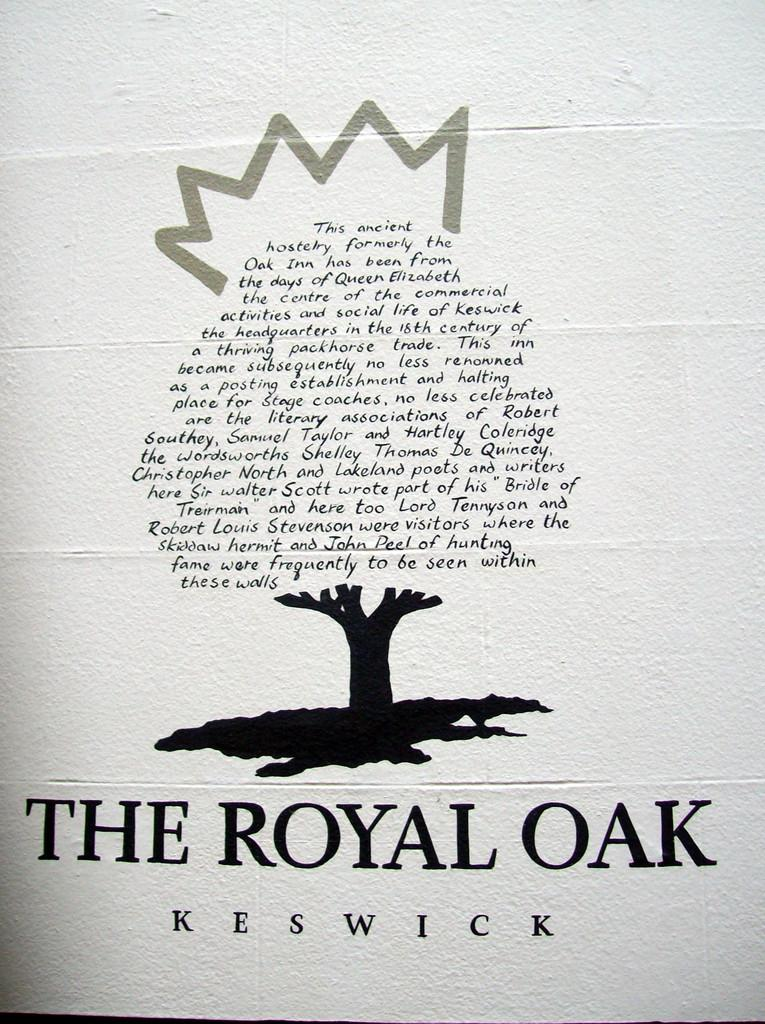Provide a one-sentence caption for the provided image. A white book has a tree designed on it and has the title the royal oak written on it. 